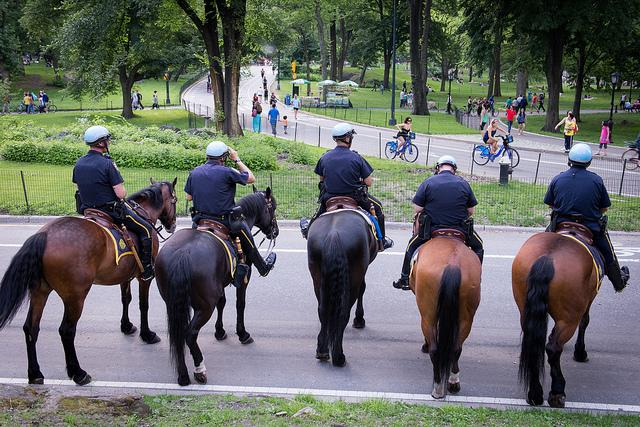What setting do these mounted persons stand in? Please explain your reasoning. park. The setting is a park. 